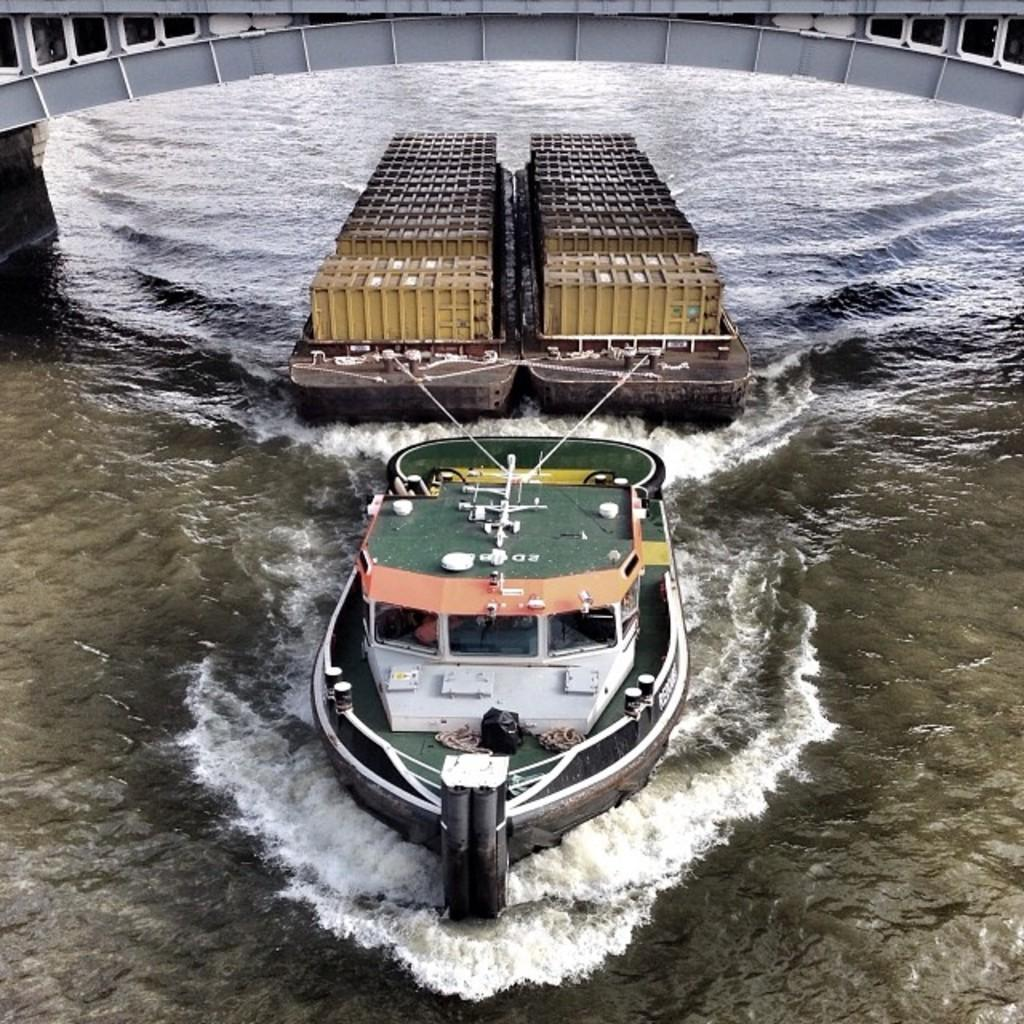What is in the water in the image? There is a boat in the water. What is attached to the boat with ropes? There are two brown objects tied to the boat with ropes. What can be seen on the brown objects? There are items visible on the brown objects. What type of shoes can be seen on the arm of the person in the image? There is no person or arm visible in the image; it only features a boat, brown objects, and items on those objects. 